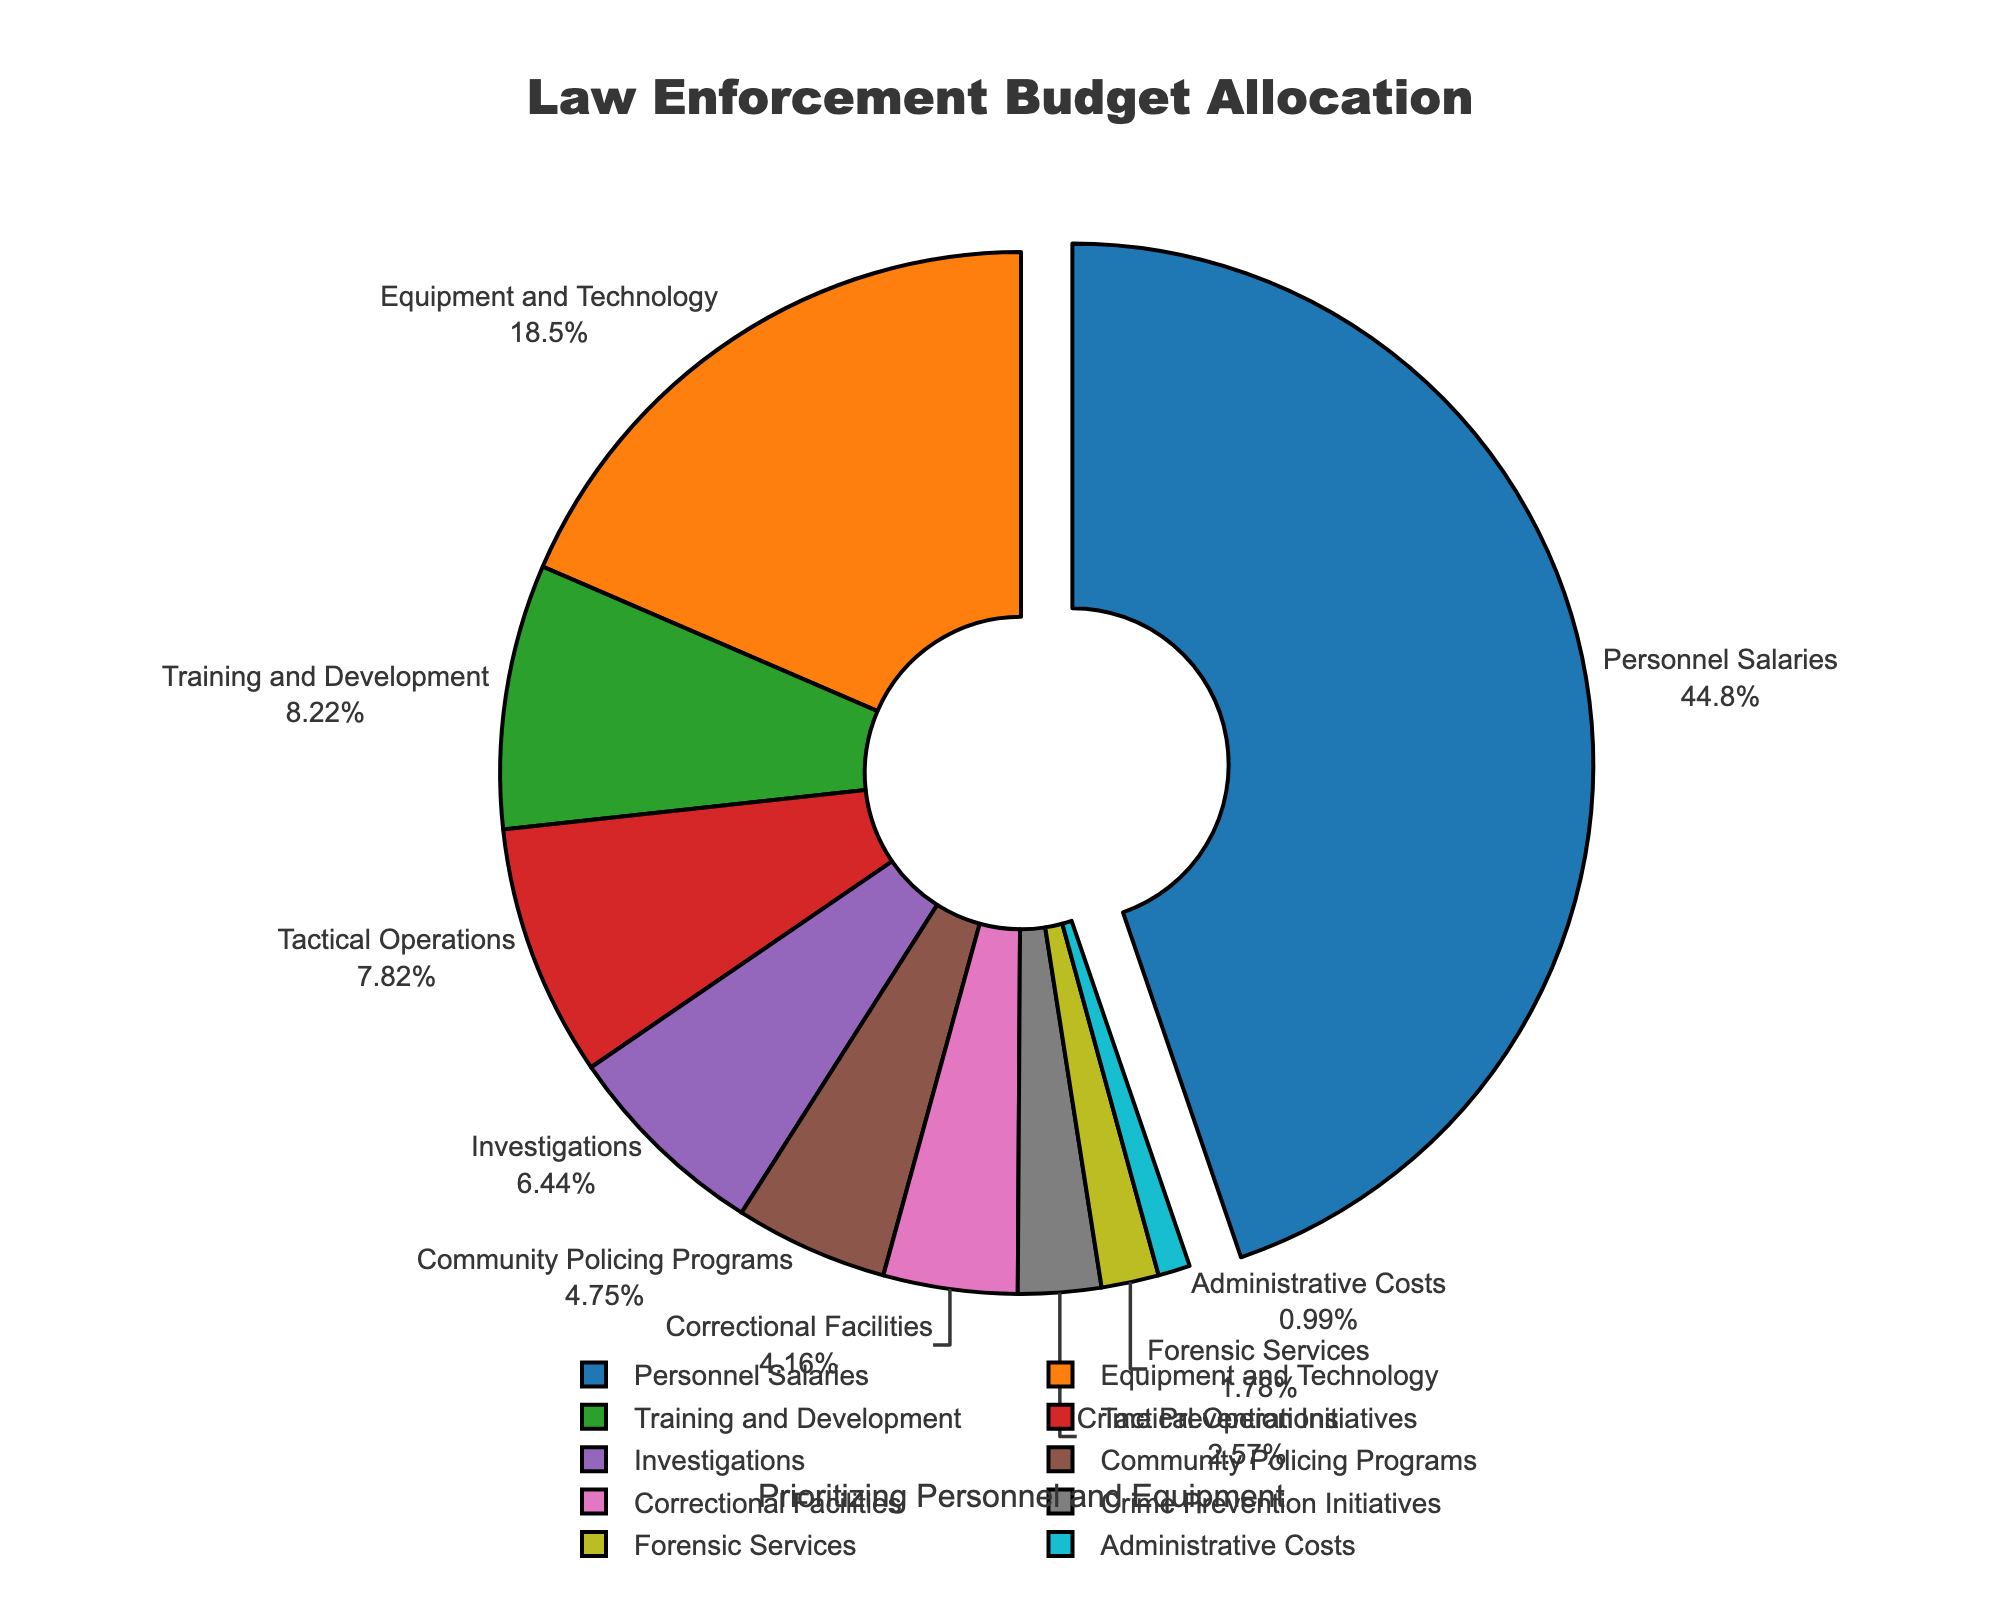What's the largest allocation category in the law enforcement budget? From the pie chart, the largest segment is for "Personnel Salaries" which occupies the largest portion of the pie chart, highlighted with a slight pull from the center for emphasis.
Answer: Personnel Salaries How much higher is the allocation for Personnel Salaries compared to Training and Development? The percentage allocated for Personnel Salaries is 45.2%, and for Training and Development, it's 8.3%. The difference is calculated as 45.2% - 8.3% = 36.9%.
Answer: 36.9% What are the two smallest categories in the budget allocation? By observing the smallest slices in the pie chart, "Administrative Costs" at 1.0% and "Forensic Services" at 1.8% are the smallest segments.
Answer: Administrative Costs and Forensic Services How does the budget for Equipment and Technology compare to Crime Prevention Initiatives? The percentage for Equipment and Technology is 18.7%, while Crime Prevention Initiatives is 2.6%. Equipment and Technology (18.7%) have a considerably larger portion than Crime Prevention Initiatives (2.6%).
Answer: Greater What is the combined percentage for Tactical Operations, Investigations, and Community Policing Programs? Adding the percentages: Tactical Operations (7.9%), Investigations (6.5%), and Community Policing Programs (4.8%), gives a total of 7.9% + 6.5% + 4.8% = 19.2%.
Answer: 19.2% What categories make up more than 10% of the budget allocation? Only "Personnel Salaries" (45.2%) and "Equipment and Technology" (18.7%) are above 10%, as indicated by their larger sections in the pie chart.
Answer: Personnel Salaries and Equipment and Technology Which category related to crime reduction has the lowest budget allocation, and what percentage is it? Crime Prevention Initiatives is directly concerned with crime reduction and has the smallest allocation of 2.6%, as observed from the pie chart.
Answer: Crime Prevention Initiatives at 2.6% 